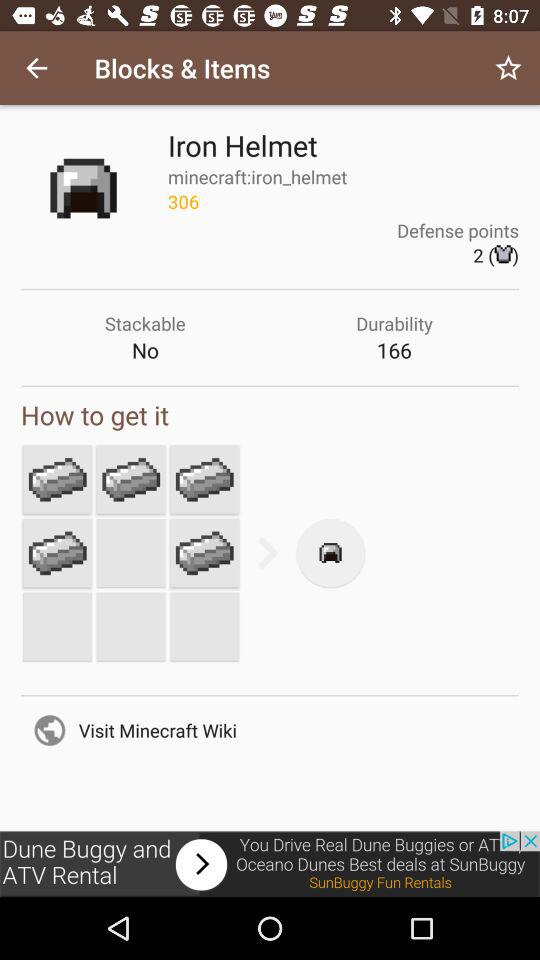What's the "Stackable" status? The status is "No". 